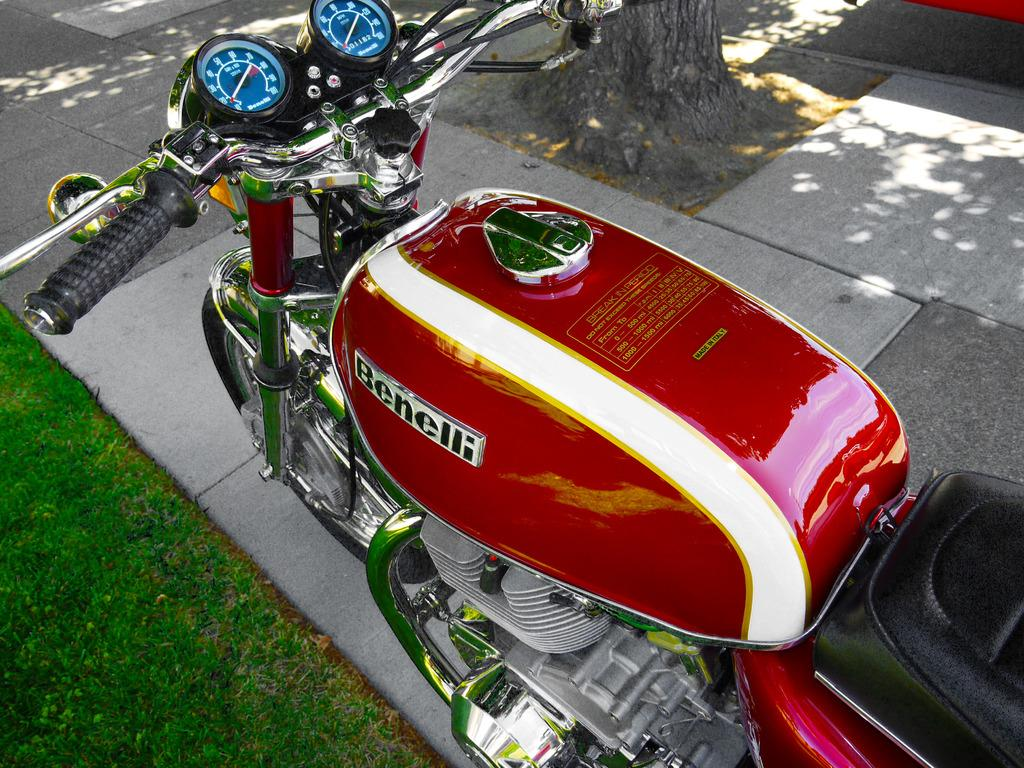What can be seen on the footpath in the image? There is a bike on a footpath in the image. What type of vegetation is present on the ground in the image? There is grass on the ground in the left bottom corner of the image. What is the condition of the tree in the image? There is a truncated tree at the top of the image. What object is present on the road in the image? There is an object on the road in the image. What type of bell can be heard ringing in the image? There is no bell present in the image, and therefore no sound can be heard. 